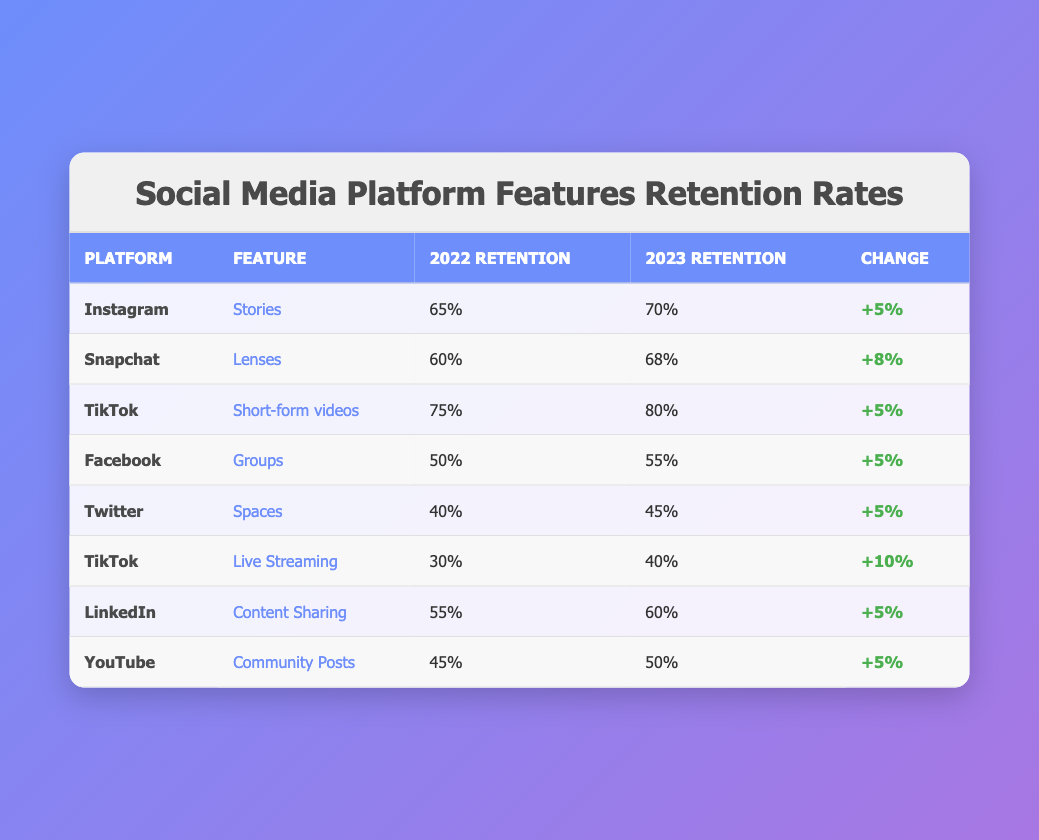What was the retention rate for TikTok's Live Streaming in 2023? The table shows that the retention rate for TikTok's Live Streaming for 2023 is listed in the corresponding row under the "2023 Retention" column, which indicates a retention rate of 40%.
Answer: 40% Which platform had the highest retention rate of any feature in 2022? Looking at the "2022 Retention" column across all platforms, TikTok's Short-form videos have the highest retention rate at 75%, which is greater than all other values in that column.
Answer: 75% Did the retention rate for Facebook's Groups feature increase in 2023? By examining the row for Facebook's Groups, we can see that the 2023 retention rate of 55% is greater than the 2022 retention rate of 50%, confirming an increase.
Answer: Yes What is the average change in retention rates across all features listed for 2023? To find the average change, sum the changes +(5 + 8 + 5 + 5 + 5 + 10 + 5 + 5 = 53) and divide by the total number of features (8), which gives 53/8 = 6.625.
Answer: 6.625 Which feature on Snapchat had the second-highest retention rate in 2023? In the table, Snapchat's Lenses feature has the second-highest retention rate of 68% in the "2023 Retention" column. The highest rate belongs to TikTok's Short-form videos at 80%.
Answer: 68% 